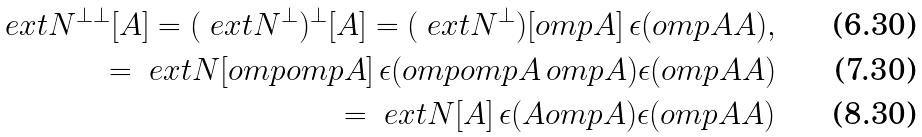Convert formula to latex. <formula><loc_0><loc_0><loc_500><loc_500>\ e x t { N } ^ { \perp \perp } [ A ] = ( \ e x t { N } ^ { \perp } ) ^ { \perp } [ A ] = ( \ e x t { N } ^ { \perp } ) [ o m p { A } ] \, \epsilon ( o m p { A } A ) , \\ = \ e x t { N } [ o m p { o m p { A } } ] \, \epsilon ( o m p { o m p { A } } \, o m p { A } ) \epsilon ( o m p { A } A ) \\ = \ e x t { N } [ A ] \, \epsilon ( A o m p { A } ) \epsilon ( o m p { A } A )</formula> 